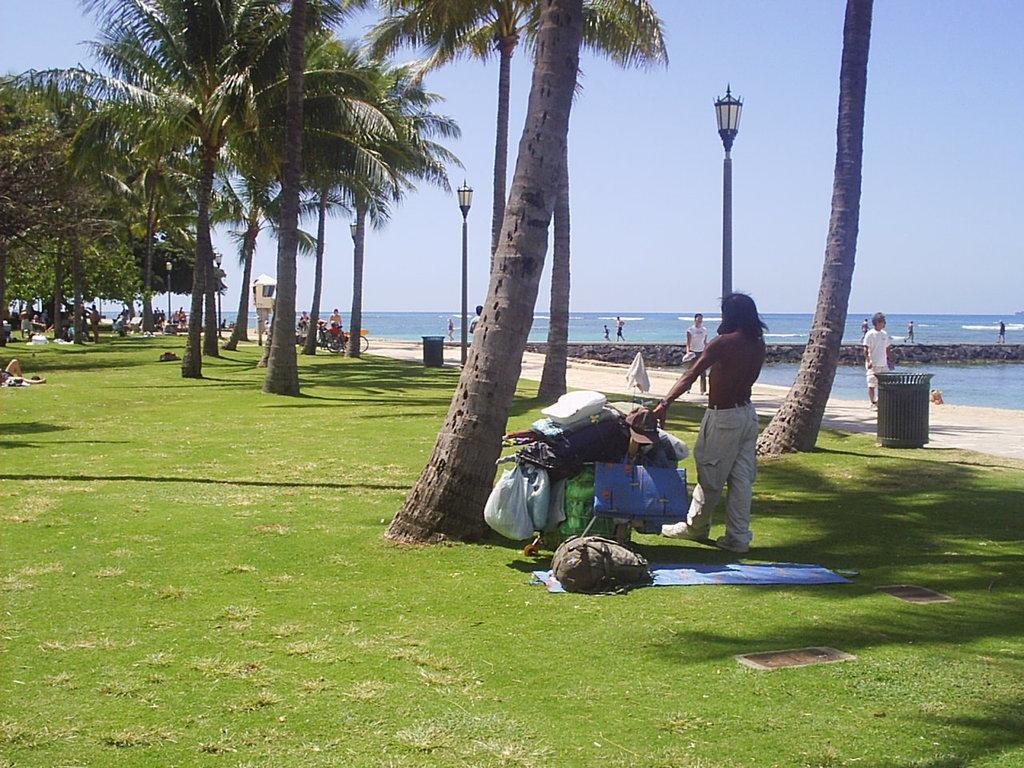What type of natural elements can be seen in the image? There are trees in the image. Are there any living beings present in the image? Yes, there are people in the image. What other objects can be seen at the bottom of the image? There are other objects at the bottom of the image, but their specific details are not mentioned in the facts. What is visible in the background of the image? There is a surface of water in the background of the image. What is visible at the top of the image? There is a sky at the top of the image. Can you tell me how many times the person in the image kicks the vest? There is no mention of a vest or any kicking action in the image. The image features trees, people, other objects, a surface of water, and a sky. 